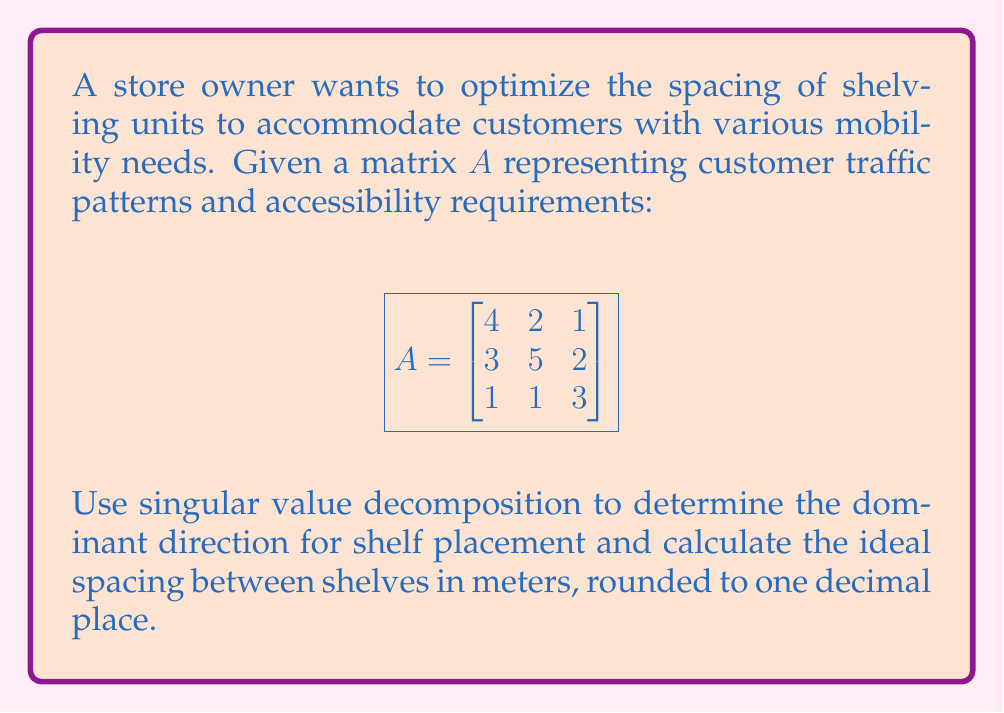What is the answer to this math problem? 1) First, we need to perform Singular Value Decomposition (SVD) on matrix A:
   $A = U\Sigma V^T$

2) Calculate $A^TA$:
   $$A^TA = \begin{bmatrix}
   4 & 3 & 1 \\
   2 & 5 & 1 \\
   1 & 2 & 3
   \end{bmatrix} \begin{bmatrix}
   4 & 2 & 1 \\
   3 & 5 & 2 \\
   1 & 1 & 3
   \end{bmatrix} = \begin{bmatrix}
   26 & 23 & 13 \\
   23 & 34 & 17 \\
   13 & 17 & 14
   \end{bmatrix}$$

3) Find eigenvalues of $A^TA$ by solving $\det(A^TA - \lambda I) = 0$:
   $\lambda_1 \approx 60.62$, $\lambda_2 \approx 12.31$, $\lambda_3 \approx 1.07$

4) The singular values are the square roots of these eigenvalues:
   $\sigma_1 \approx 7.79$, $\sigma_2 \approx 3.51$, $\sigma_3 \approx 1.03$

5) The largest singular value $\sigma_1 \approx 7.79$ corresponds to the dominant direction.

6) Calculate the corresponding right singular vector $v_1$ (eigenvector of $A^TA$):
   $v_1 \approx [0.62, 0.71, 0.33]^T$

7) This vector represents the optimal direction for shelf placement.

8) The ideal spacing is inversely proportional to the largest singular value.
   Let's assume a scaling factor of 10 for practicality.
   Ideal spacing $= \frac{10}{\sigma_1} \approx \frac{10}{7.79} \approx 1.28$ meters

9) Rounding to one decimal place: 1.3 meters
Answer: 1.3 meters 